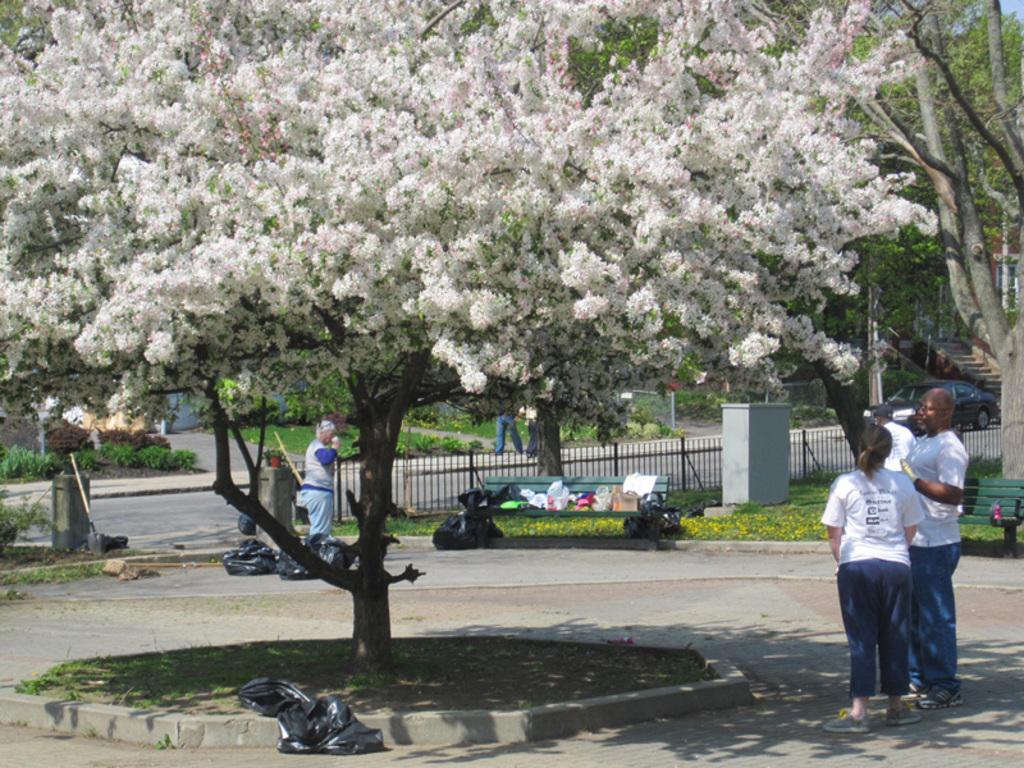In one or two sentences, can you explain what this image depicts? In this image we can see some trees, trash bags, dustbin, shovel, benches, there are some objects on the bench, there are some plants, a house, and a window, also we can see a few people, and the sky. 